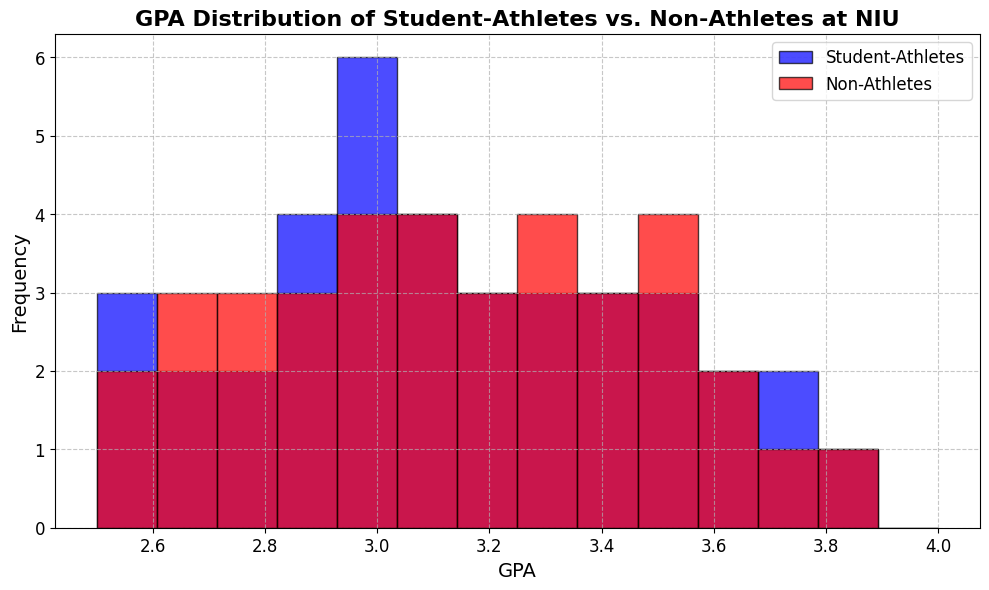What's the most common GPA range for student-athletes? The histogram shows the frequency of GPA ranges. For student-athletes, it appears that the bins around 3.0 to 3.2 have the highest bars. This indicates the GPA range of 3.0 to 3.2 is the most common among student-athletes.
Answer: 3.0 to 3.2 Which group has a higher frequency of GPAs in the 3.4 to 3.6 range? By examining the histogram, we can compare the height of the blue (student-athletes) bar to the red (non-athletes) bar within the 3.4 to 3.6 range. The red bar is higher, indicating that non-athletes have a higher frequency in this range.
Answer: Non-athletes Are there any GPA ranges where both student-athletes and non-athletes have the same frequency? We need to look for GPA ranges where the bars for both student-athletes and non-athletes are of equal height. In the range of 2.7 to 2.9, both groups seem to have bars of similar height.
Answer: 2.7 to 2.9 What is the combined frequency of student-athletes with a GPA between 2.5 and 2.7? To find the combined frequency, we add the frequencies of student-athletes in the 2.5 to 2.6 and 2.6 to 2.7 bins. The histogram shows approximately 1 student-athlete in the 2.5 to 2.6 range and 2 in the 2.6 to 2.7 range, totaling 3.
Answer: 3 Which GPA range has the least frequency for both groups combined? By comparing the heights of all bars, the shortest bars indicating the least frequency are found in the 3.8 to 4.0 GPA range.
Answer: 3.8 to 4.0 How can you tell the distribution of GPAs for student-athletes compared to non-athletes? By examining the shape and spread of the histograms, student-athletes have a more even distribution with peaks around 3.0 to 3.2, while non-athletes have a slightly higher frequency around 3.4 to 3.6.
Answer: Student-athletes are more evenly distributed around 3.0-3.2, non-athletes peak at 3.4-3.6 What is the approximate total number of non-athletes with a GPA over 3.5? The bars for non-athletes over 3.5 are in the 3.5 to 3.6, 3.6 to 3.7, 3.7 to 3.8, and 3.8 to 4.0 ranges. The approximate counts from the histogram are: 3, 2, 1, and 1 respectively, summing to 7.
Answer: 7 In the GPA range of 2.8 to 3.0, how does the frequency of student-athletes compare to non-athletes? We compare the heights of the blue bar (student-athletes) and red bar (non-athletes) in the 2.8 to 3.0 range. The heights are similar, indicating a nearly equal frequency.
Answer: Nearly equal Is there a visible trend in the GPA distribution for student-athletes? The histogram for student-athletes shows that most have GPAs around 3.0-3.2, tapering off towards both extremes, indicating a central tendency and fewer student-athletes at lower and higher ends.
Answer: Central tendency around 3.0-3.2 